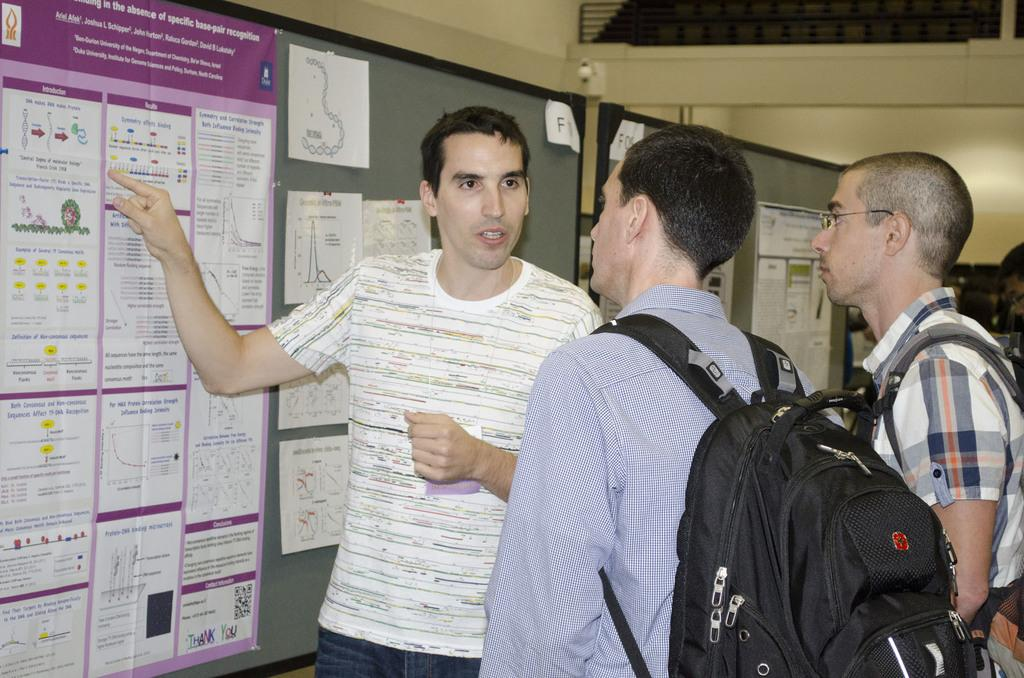<image>
Share a concise interpretation of the image provided. A man is pointing to his poster, which is about base-pair recognition. 